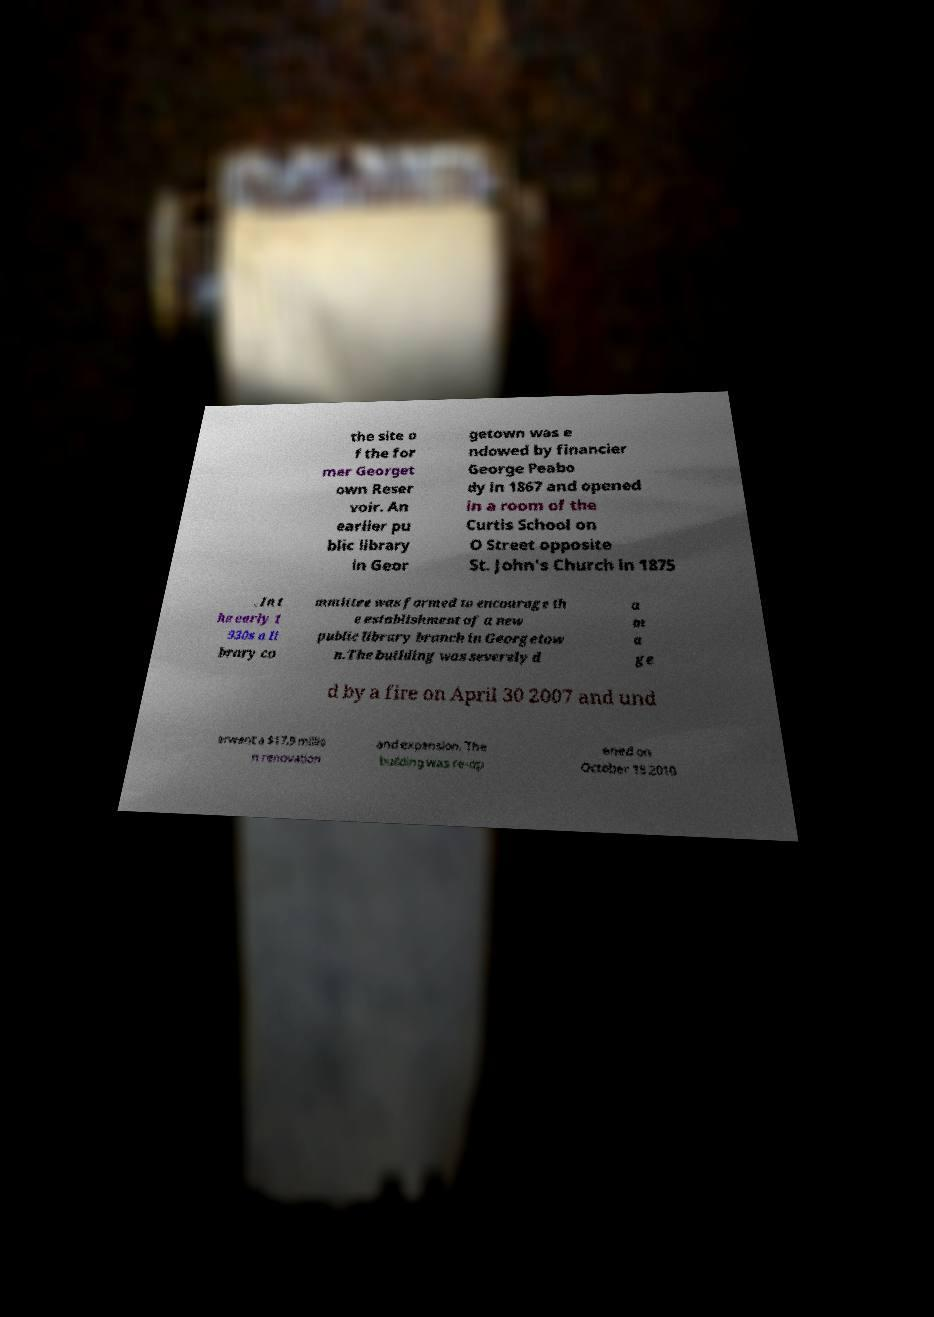Could you assist in decoding the text presented in this image and type it out clearly? the site o f the for mer Georget own Reser voir. An earlier pu blic library in Geor getown was e ndowed by financier George Peabo dy in 1867 and opened in a room of the Curtis School on O Street opposite St. John's Church in 1875 . In t he early 1 930s a li brary co mmittee was formed to encourage th e establishment of a new public library branch in Georgetow n.The building was severely d a m a ge d by a fire on April 30 2007 and und erwent a $17.9 millio n renovation and expansion. The building was re-op ened on October 18 2010 